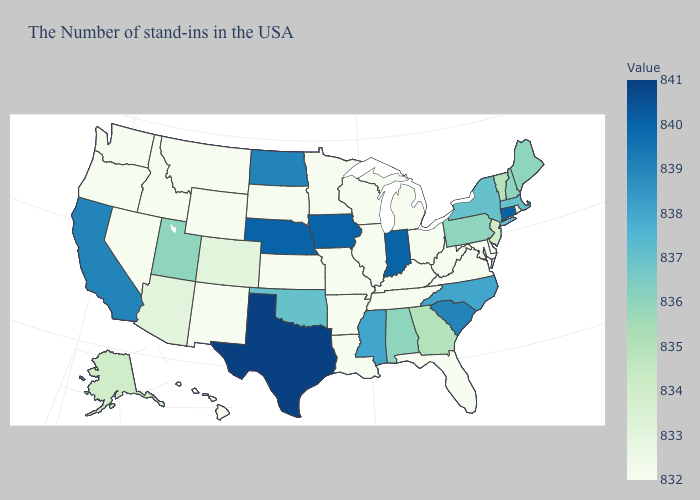Does Oregon have the lowest value in the USA?
Concise answer only. Yes. Among the states that border Ohio , does Michigan have the lowest value?
Quick response, please. Yes. Which states hav the highest value in the Northeast?
Quick response, please. Connecticut. Does the map have missing data?
Answer briefly. No. Does New Jersey have the highest value in the Northeast?
Keep it brief. No. Among the states that border Pennsylvania , does Ohio have the highest value?
Be succinct. No. Does Wyoming have a lower value than Texas?
Write a very short answer. Yes. Which states have the lowest value in the MidWest?
Give a very brief answer. Ohio, Michigan, Wisconsin, Illinois, Missouri, Minnesota, Kansas, South Dakota. 